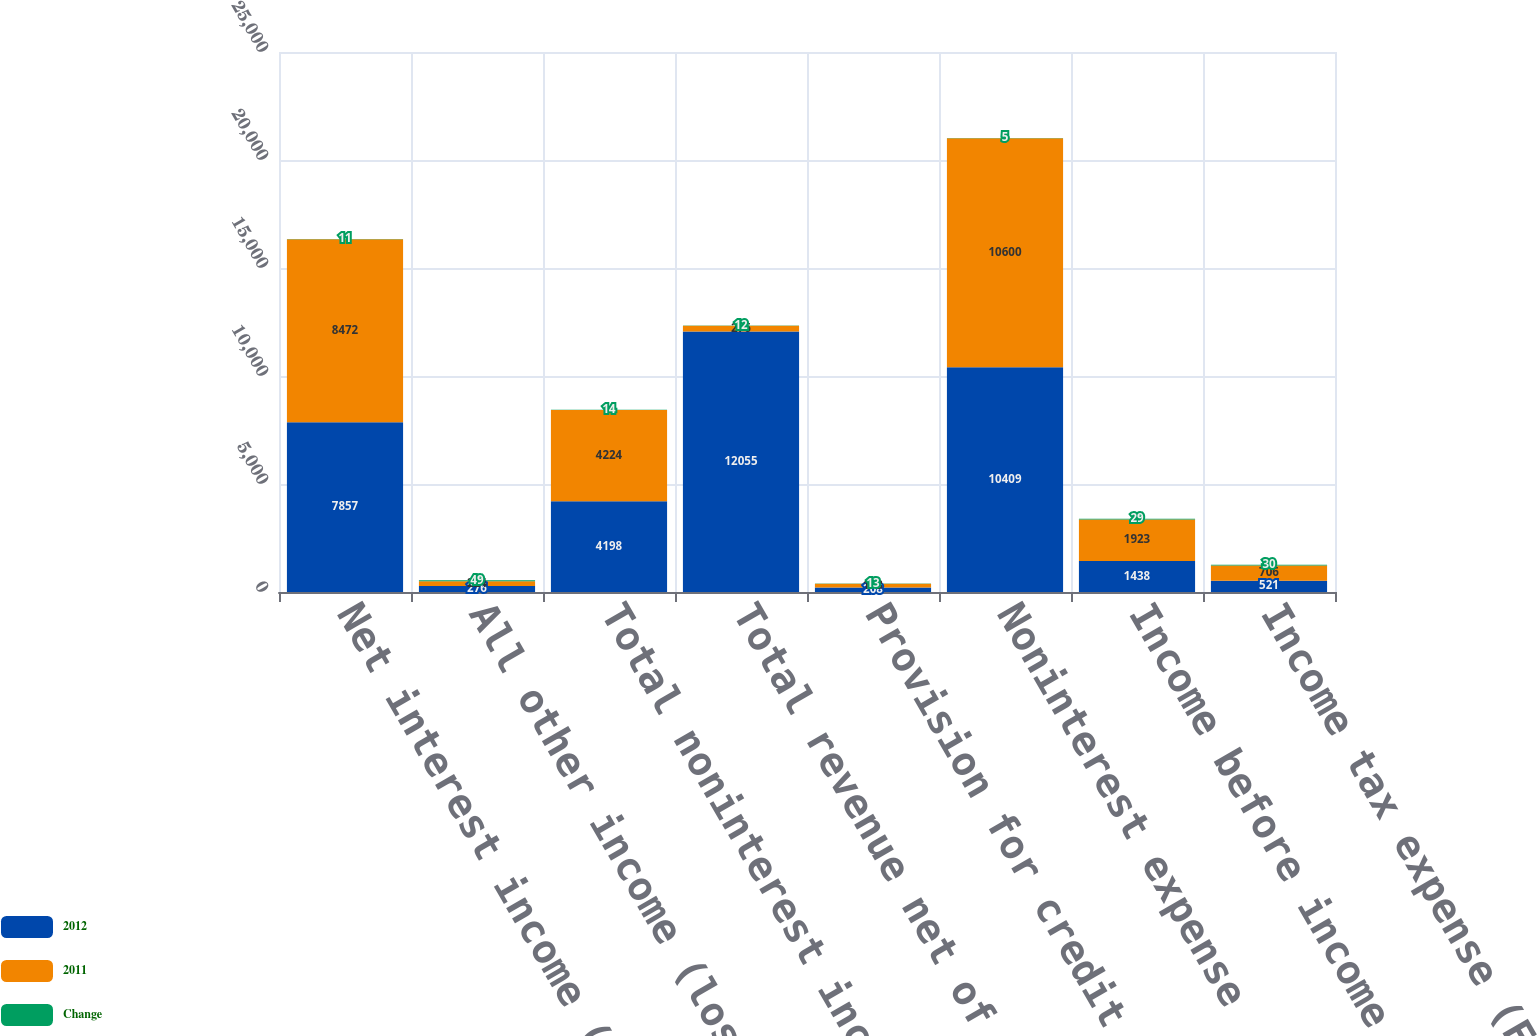Convert chart. <chart><loc_0><loc_0><loc_500><loc_500><stacked_bar_chart><ecel><fcel>Net interest income (FTE<fcel>All other income (loss)<fcel>Total noninterest income<fcel>Total revenue net of interest<fcel>Provision for credit losses<fcel>Noninterest expense<fcel>Income before income taxes<fcel>Income tax expense (FTE basis)<nl><fcel>2012<fcel>7857<fcel>276<fcel>4198<fcel>12055<fcel>208<fcel>10409<fcel>1438<fcel>521<nl><fcel>2011<fcel>8472<fcel>224<fcel>4224<fcel>276<fcel>173<fcel>10600<fcel>1923<fcel>706<nl><fcel>Change<fcel>11<fcel>49<fcel>14<fcel>12<fcel>13<fcel>5<fcel>29<fcel>30<nl></chart> 